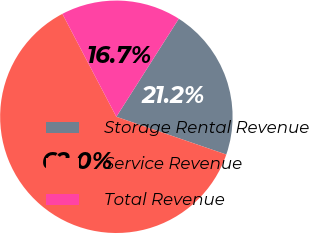Convert chart to OTSL. <chart><loc_0><loc_0><loc_500><loc_500><pie_chart><fcel>Storage Rental Revenue<fcel>Service Revenue<fcel>Total Revenue<nl><fcel>21.24%<fcel>62.05%<fcel>16.71%<nl></chart> 